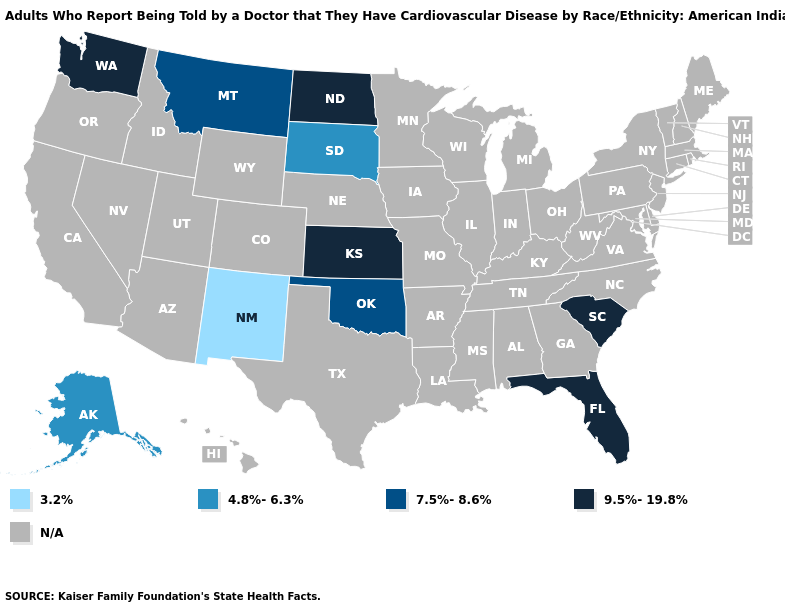Name the states that have a value in the range 7.5%-8.6%?
Give a very brief answer. Montana, Oklahoma. What is the lowest value in the West?
Quick response, please. 3.2%. Among the states that border Colorado , which have the highest value?
Answer briefly. Kansas. Does the map have missing data?
Write a very short answer. Yes. Name the states that have a value in the range N/A?
Short answer required. Alabama, Arizona, Arkansas, California, Colorado, Connecticut, Delaware, Georgia, Hawaii, Idaho, Illinois, Indiana, Iowa, Kentucky, Louisiana, Maine, Maryland, Massachusetts, Michigan, Minnesota, Mississippi, Missouri, Nebraska, Nevada, New Hampshire, New Jersey, New York, North Carolina, Ohio, Oregon, Pennsylvania, Rhode Island, Tennessee, Texas, Utah, Vermont, Virginia, West Virginia, Wisconsin, Wyoming. Which states have the lowest value in the USA?
Short answer required. New Mexico. What is the value of New York?
Quick response, please. N/A. What is the value of Missouri?
Be succinct. N/A. What is the value of Vermont?
Give a very brief answer. N/A. Does South Carolina have the highest value in the South?
Short answer required. Yes. What is the highest value in states that border Utah?
Write a very short answer. 3.2%. What is the lowest value in the USA?
Keep it brief. 3.2%. How many symbols are there in the legend?
Short answer required. 5. What is the value of California?
Answer briefly. N/A. 